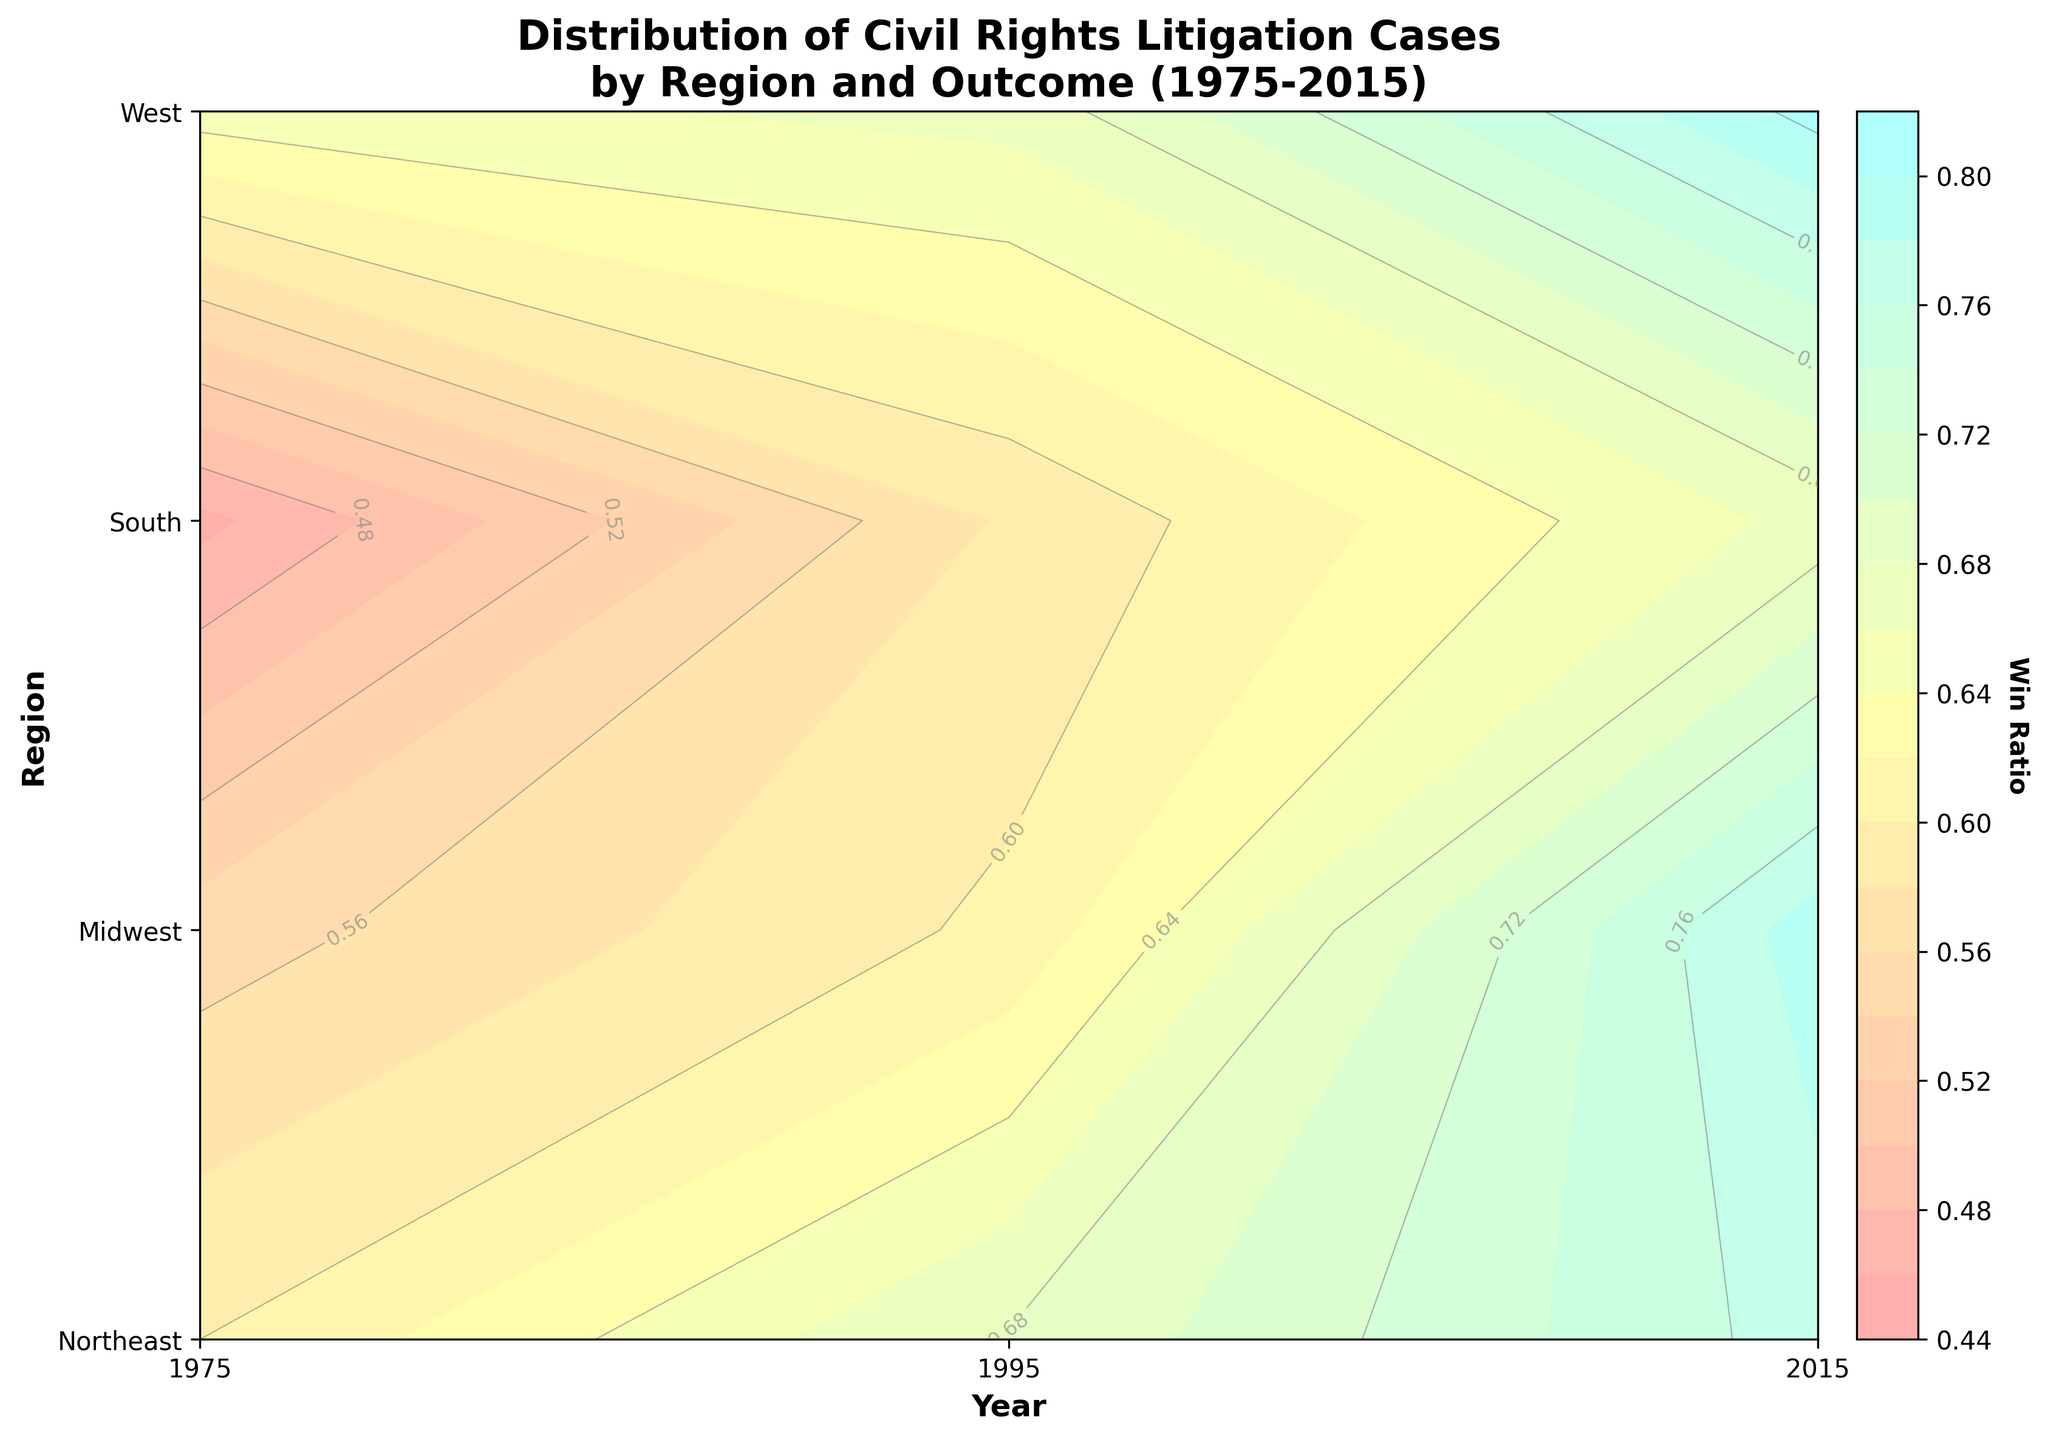What is the title of the figure? The title is always displayed at the top of the figure. It succinctly describes what is being shown or analyzed in the plot.
Answer: Distribution of Civil Rights Litigation Cases by Region and Outcome (1975-2015) What regions are included in this plot? The y-axis of the figure lists all the regions included. The labels next to the ticks indicate the regions.
Answer: Northeast, Midwest, South, West Which region had the highest win ratio in 2015? Locate the year 2015 on the x-axis, and then look at the respective color intensity for each region. The highest win ratio will have the lightest color.
Answer: West Did the win ratio for the Northeast increase or decrease from 1975 to 2015? Compare the color intensity for Northeast in 1975 and 2015 along the x-axis. If the color becomes lighter, the win ratio increased; if darker, it decreased.
Answer: Increase What does a lighter color on the plot represent? The color bar shows that lighter colors indicate higher win ratios, as depicted in the visual gradient from darker to lighter.
Answer: Higher win ratio Which region showed the most significant improvement in win ratio from 1975 to 2015? Compare the change in color intensity from 1975 to 2015 for all regions. The region with the most significant change to a lighter color had the biggest improvement in win ratio.
Answer: Midwest How does the win ratio in the South in 1995 compare to that in the West in 1995? Find the two points in the plot corresponding to the South in 1995 and the West in 1995. Compare their colors: lighter color indicates a higher win ratio.
Answer: The West had a higher win ratio What trend can be observed about the win ratios in the Northeast and Midwest over the years 1975, 1995, and 2015? Observe the change in color intensity for Northeast and Midwest across the years 1975, 1995, and 2015. Identify if the colors get progressively lighter, indicating an increase in win ratio over time.
Answer: Both regions show an increasing trend in win ratios Which year shows the highest average win ratio across all regions? Find the average win ratio by visually comparing the color intensity across all regions for a given year. The year with the most consistently light colors across all regions has the highest average win ratio.
Answer: 2015 